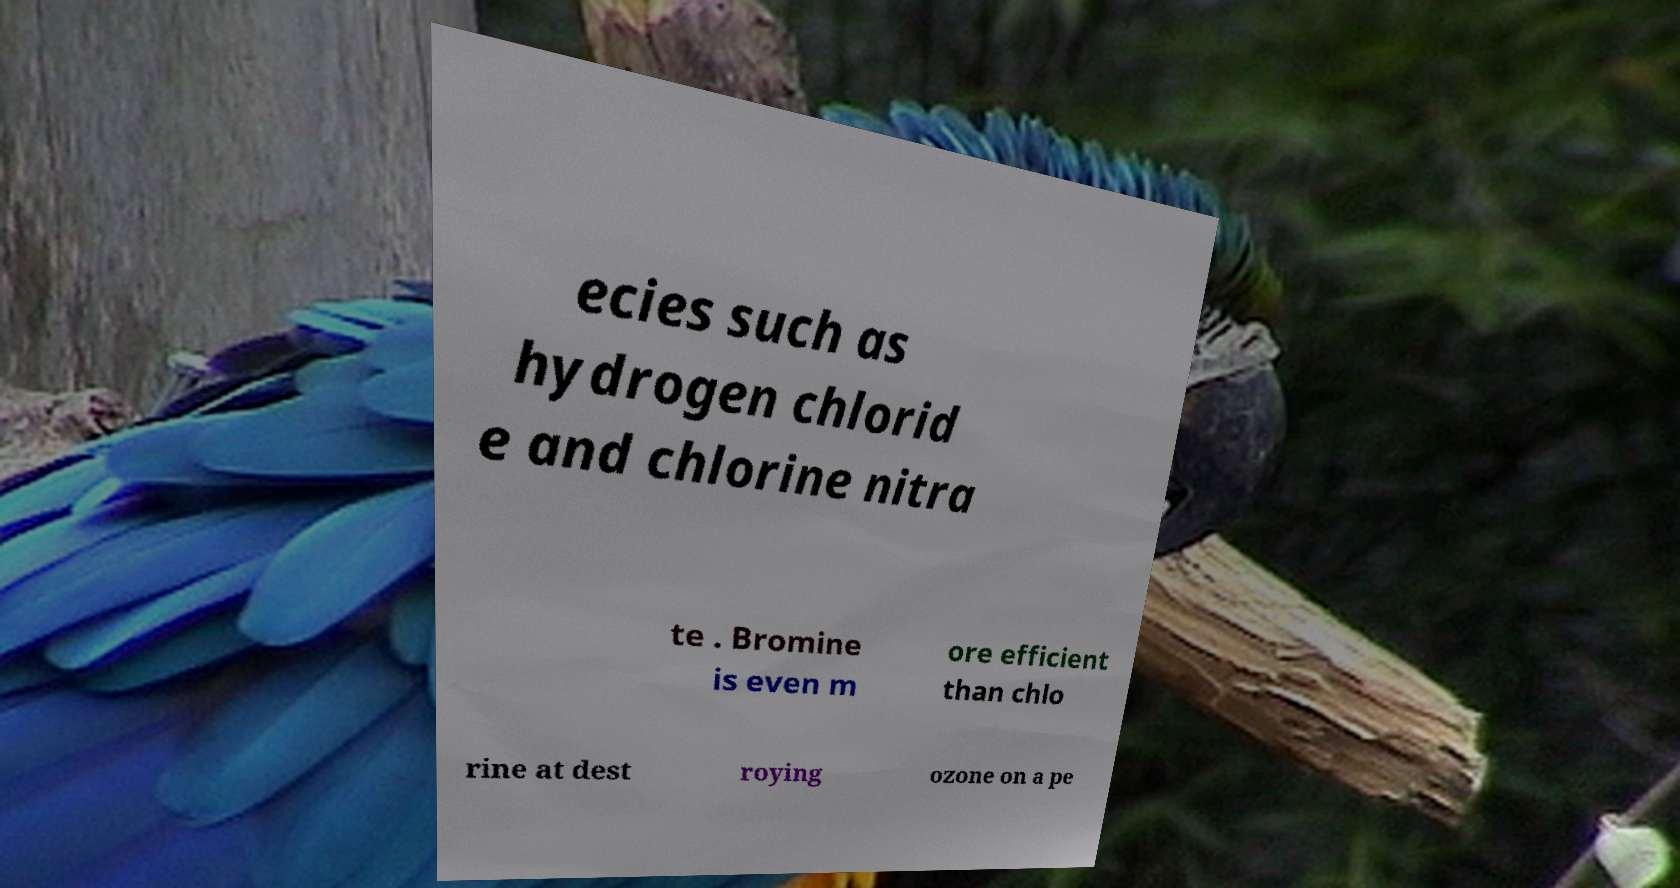I need the written content from this picture converted into text. Can you do that? ecies such as hydrogen chlorid e and chlorine nitra te . Bromine is even m ore efficient than chlo rine at dest roying ozone on a pe 